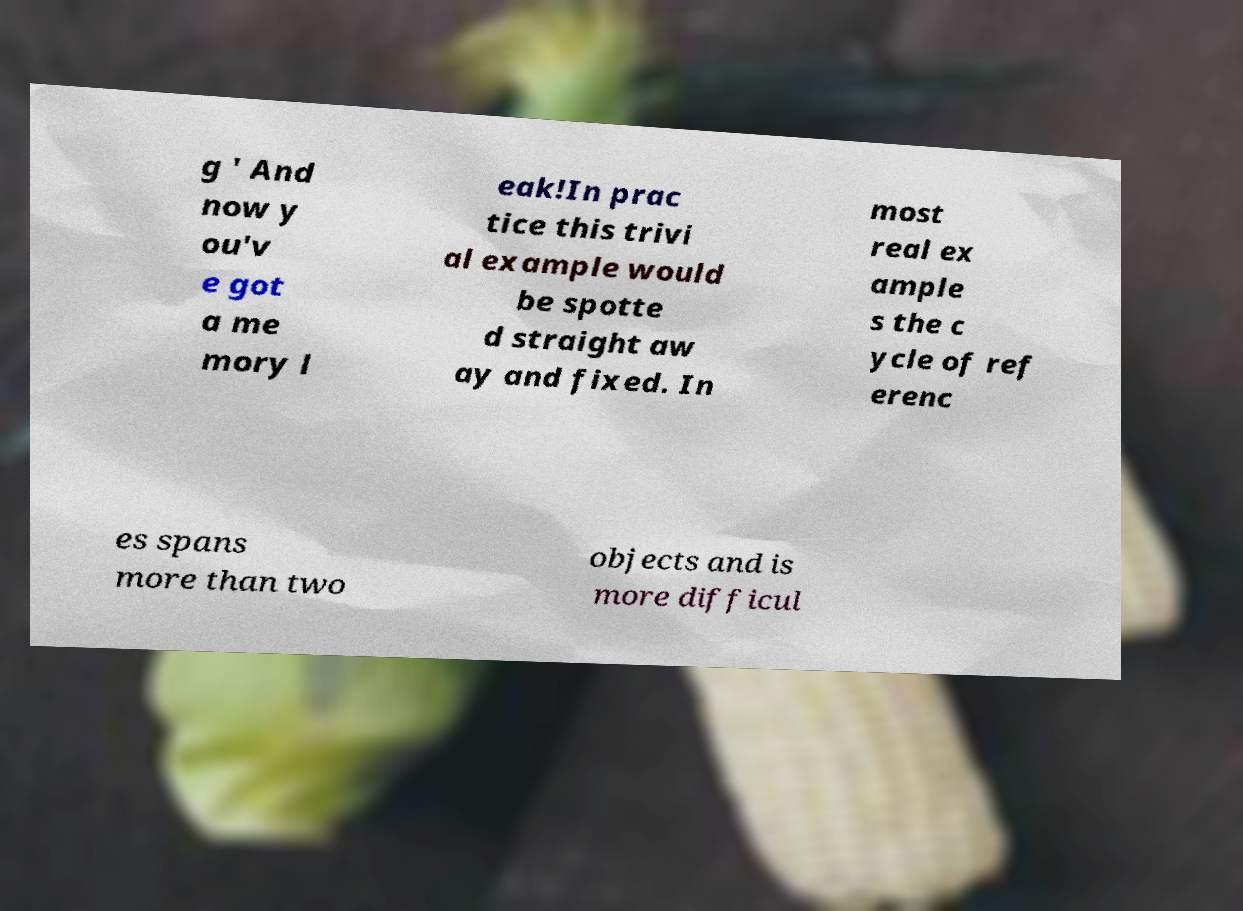There's text embedded in this image that I need extracted. Can you transcribe it verbatim? g ' And now y ou'v e got a me mory l eak!In prac tice this trivi al example would be spotte d straight aw ay and fixed. In most real ex ample s the c ycle of ref erenc es spans more than two objects and is more difficul 